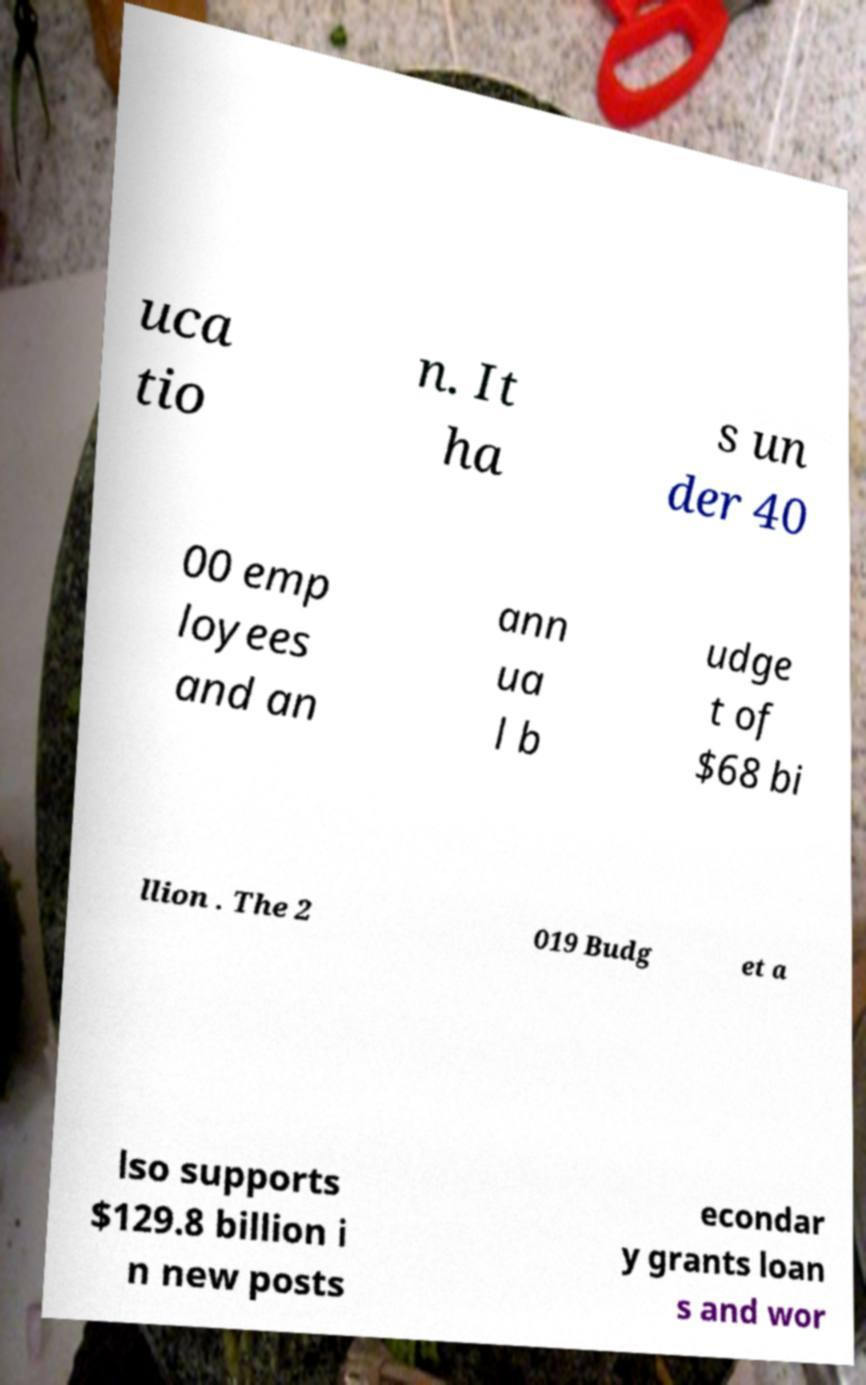Can you read and provide the text displayed in the image?This photo seems to have some interesting text. Can you extract and type it out for me? uca tio n. It ha s un der 40 00 emp loyees and an ann ua l b udge t of $68 bi llion . The 2 019 Budg et a lso supports $129.8 billion i n new posts econdar y grants loan s and wor 